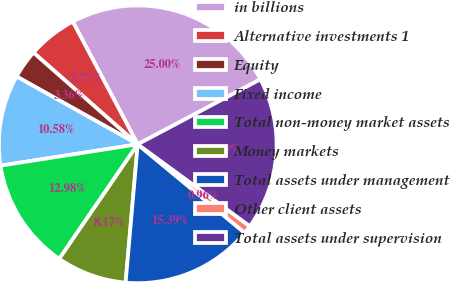Convert chart to OTSL. <chart><loc_0><loc_0><loc_500><loc_500><pie_chart><fcel>in billions<fcel>Alternative investments 1<fcel>Equity<fcel>Fixed income<fcel>Total non-money market assets<fcel>Money markets<fcel>Total assets under management<fcel>Other client assets<fcel>Total assets under supervision<nl><fcel>25.0%<fcel>5.77%<fcel>3.36%<fcel>10.58%<fcel>12.98%<fcel>8.17%<fcel>15.39%<fcel>0.96%<fcel>17.79%<nl></chart> 